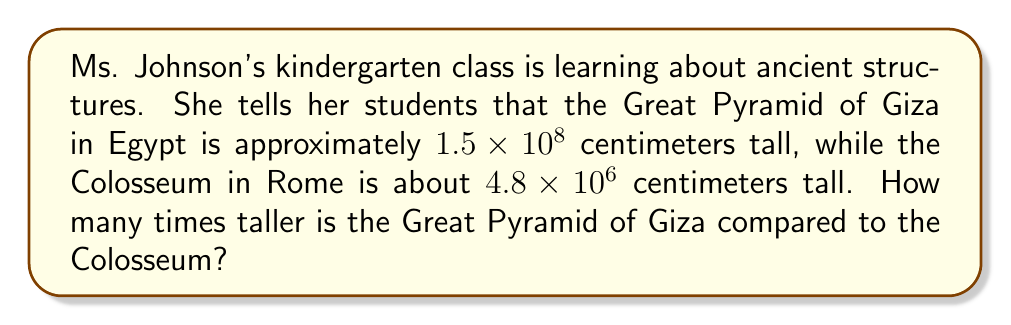Show me your answer to this math problem. To solve this problem, we need to divide the height of the Great Pyramid of Giza by the height of the Colosseum. Let's break it down step by step:

1. Height of the Great Pyramid of Giza: $1.5 \times 10^8$ cm
2. Height of the Colosseum: $4.8 \times 10^6$ cm

To divide these numbers, we can use the properties of exponents:

$$\frac{1.5 \times 10^8}{4.8 \times 10^6} = \frac{1.5}{4.8} \times \frac{10^8}{10^6}$$

First, let's simplify the fraction of the coefficients:
$$\frac{1.5}{4.8} = 0.3125$$

Now, let's simplify the exponents:
$$\frac{10^8}{10^6} = 10^{8-6} = 10^2 = 100$$

Multiplying these results:
$$0.3125 \times 100 = 31.25$$

Therefore, the Great Pyramid of Giza is 31.25 times taller than the Colosseum.
Answer: The Great Pyramid of Giza is 31.25 times taller than the Colosseum. 